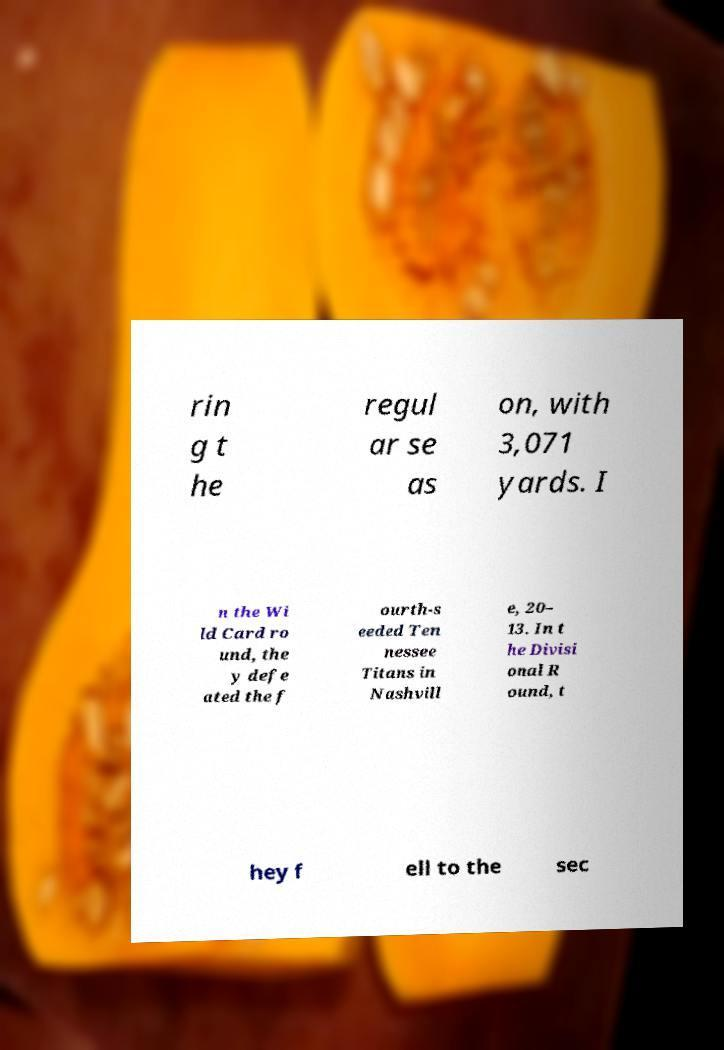Please identify and transcribe the text found in this image. rin g t he regul ar se as on, with 3,071 yards. I n the Wi ld Card ro und, the y defe ated the f ourth-s eeded Ten nessee Titans in Nashvill e, 20– 13. In t he Divisi onal R ound, t hey f ell to the sec 